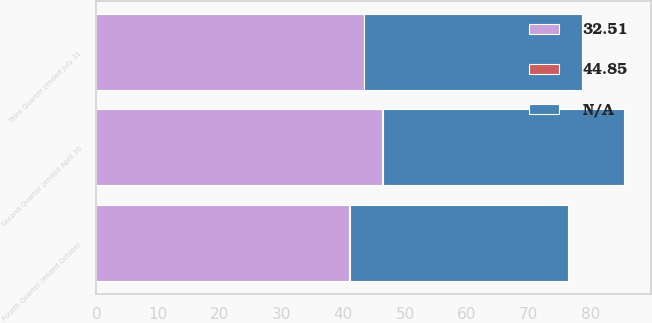Convert chart to OTSL. <chart><loc_0><loc_0><loc_500><loc_500><stacked_bar_chart><ecel><fcel>Second Quarter (ended April 30<fcel>Third Quarter (ended July 31<fcel>Fourth Quarter (ended October<nl><fcel>32.51<fcel>46.28<fcel>43.27<fcel>40.97<nl><fcel>nan<fcel>39.15<fcel>35.32<fcel>35.38<nl><fcel>44.85<fcel>0.1<fcel>0.1<fcel>0.1<nl></chart> 